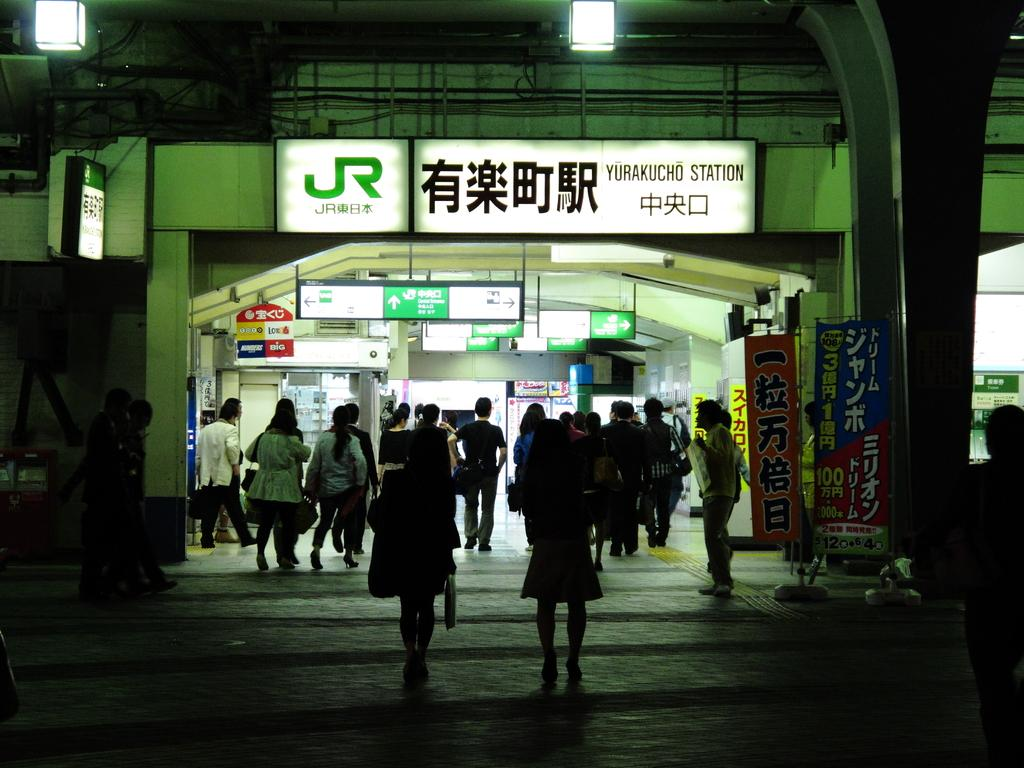<image>
Relay a brief, clear account of the picture shown. The bright white sign says JR on it 